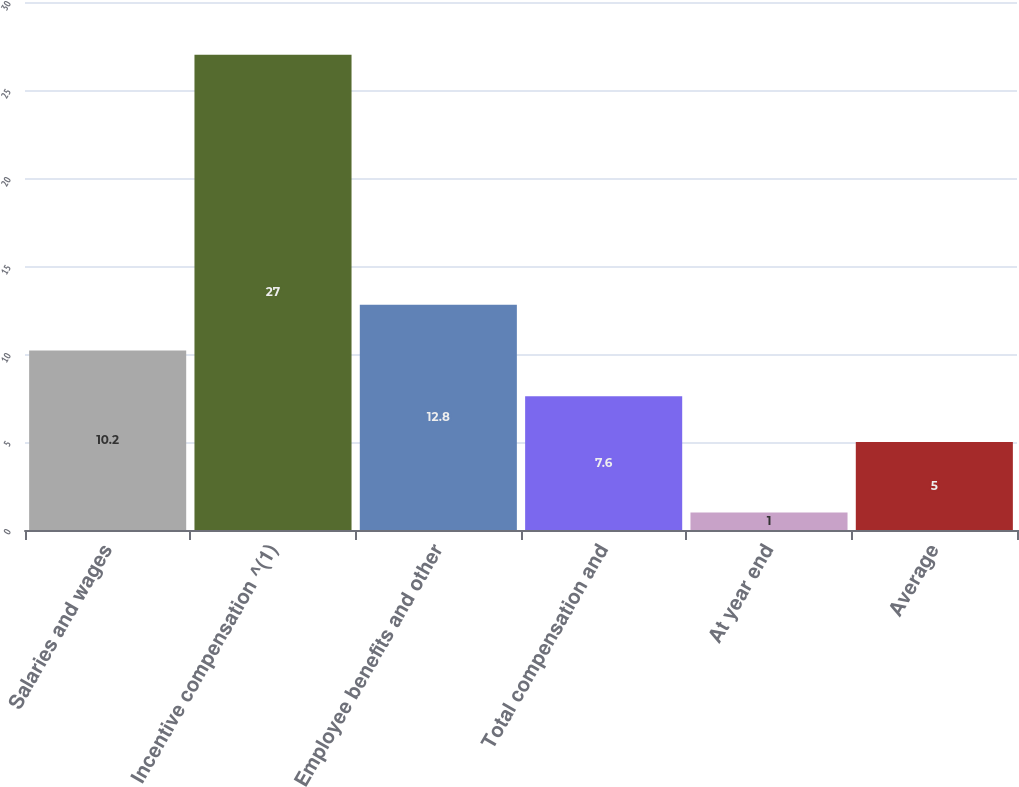Convert chart. <chart><loc_0><loc_0><loc_500><loc_500><bar_chart><fcel>Salaries and wages<fcel>Incentive compensation ^(1)<fcel>Employee benefits and other<fcel>Total compensation and<fcel>At year end<fcel>Average<nl><fcel>10.2<fcel>27<fcel>12.8<fcel>7.6<fcel>1<fcel>5<nl></chart> 